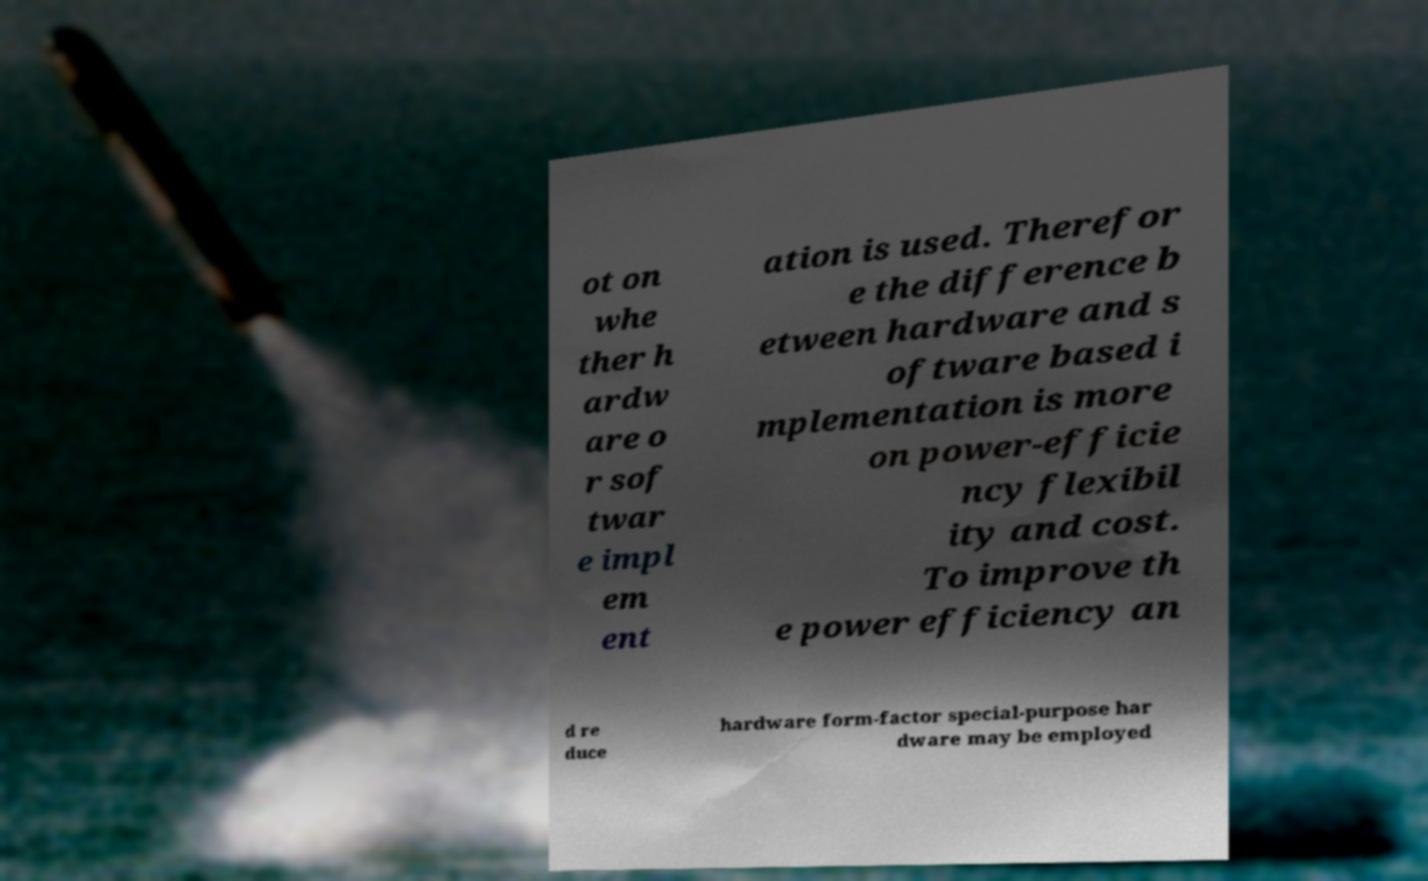Could you assist in decoding the text presented in this image and type it out clearly? ot on whe ther h ardw are o r sof twar e impl em ent ation is used. Therefor e the difference b etween hardware and s oftware based i mplementation is more on power-efficie ncy flexibil ity and cost. To improve th e power efficiency an d re duce hardware form-factor special-purpose har dware may be employed 